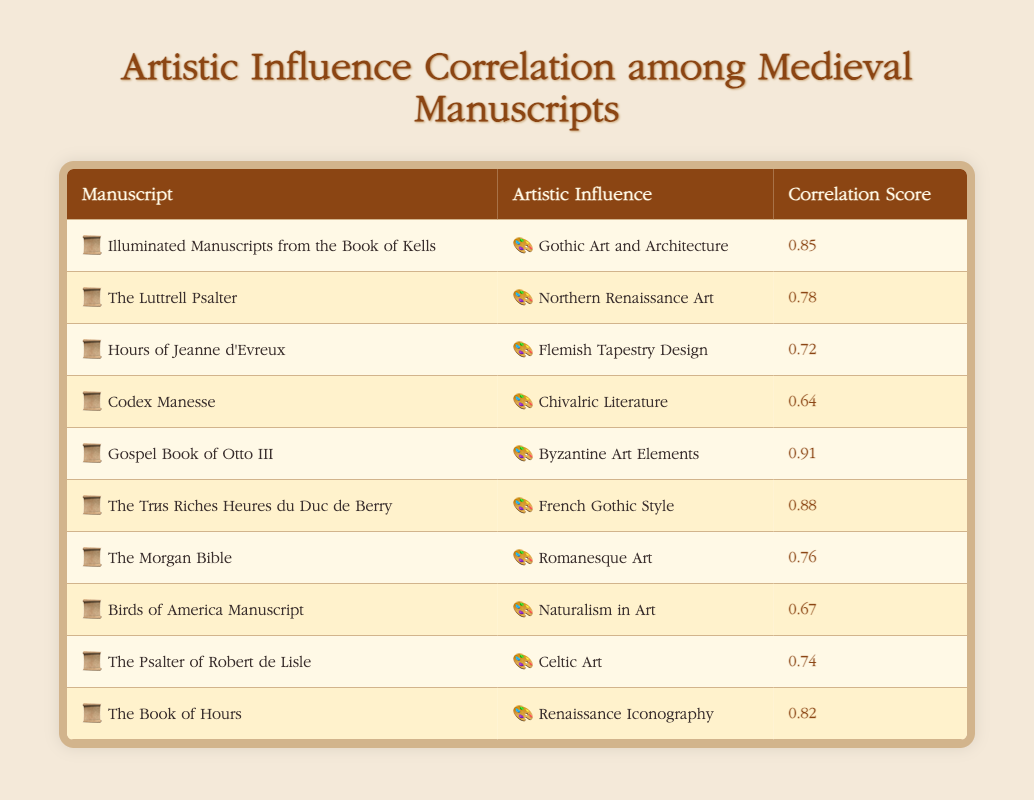What is the correlation score between the Gospel Book of Otto III and Byzantine Art Elements? The table indicates the correlation score for the relationship between the Gospel Book of Otto III and Byzantine Art Elements, which is listed as 0.91.
Answer: 0.91 Which manuscript has the highest correlation score, and what is that score? According to the table, the Gospel Book of Otto III has the highest correlation score of 0.91.
Answer: Gospel Book of Otto III, 0.91 Is the correlation score between The Luttrell Psalter and Northern Renaissance Art above 0.75? The correlation score for The Luttrell Psalter and Northern Renaissance Art is mentioned as 0.78, which is indeed above 0.75, confirming that the statement is true.
Answer: Yes Calculate the average correlation score of all the influences listed in the table. To find the average, add all the correlation scores: 0.85 + 0.78 + 0.72 + 0.64 + 0.91 + 0.88 + 0.76 + 0.67 + 0.74 + 0.82 = 7.76. There are 10 data points, so the average is 7.76/10 = 0.776.
Answer: 0.776 Which manuscript's score is closest to naturalism in art? The Birds of America Manuscript has a correlation score of 0.67, while the next score down is for the Psalter of Robert de Lisle at 0.74. Therefore, Birds of America Manuscript is the closest, as it's the only score directly associated with naturalism.
Answer: Birds of America Manuscript, 0.67 Do any manuscripts correlate with both Gothic Art and Architecture and French Gothic Style? The table lists Illuminated Manuscripts from the Book of Kells correlating with Gothic Art and Architecture at 0.85 and The Très Riches Heures du Duc de Berry correlating with French Gothic Style at 0.88. Though they have high scores, they pertain to different artistic influences and are distinct entities; thus, no single manuscript correlates to both.
Answer: No Which two influences have the lowest correlation score? Reviewing the correlation scores in the table shows that Codex Manesse and Chivalric Literature have the lowest score of 0.64. They are the pair with the weakest relationship in the dataset.
Answer: Codex Manesse and Chivalric Literature, 0.64 Is there any artistic influence with a correlation score over 0.8 that is not associated with Gothic elements? By inspecting the table, the only influence with a score over 0.8 that is not Gothic is the Gospel Book of Otto III, which connects to Byzantine Art Elements at a score of 0.91. Thus, it confirms that such an influence exists.
Answer: Yes, Gospel Book of Otto III, 0.91 What is the difference between the highest and lowest correlation scores presented? The highest correlation score is 0.91 (Gospel Book of Otto III) and the lowest is 0.64 (Codex Manesse). The difference is calculated as 0.91 - 0.64 = 0.27.
Answer: 0.27 